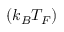Convert formula to latex. <formula><loc_0><loc_0><loc_500><loc_500>( k _ { B } T _ { F } )</formula> 